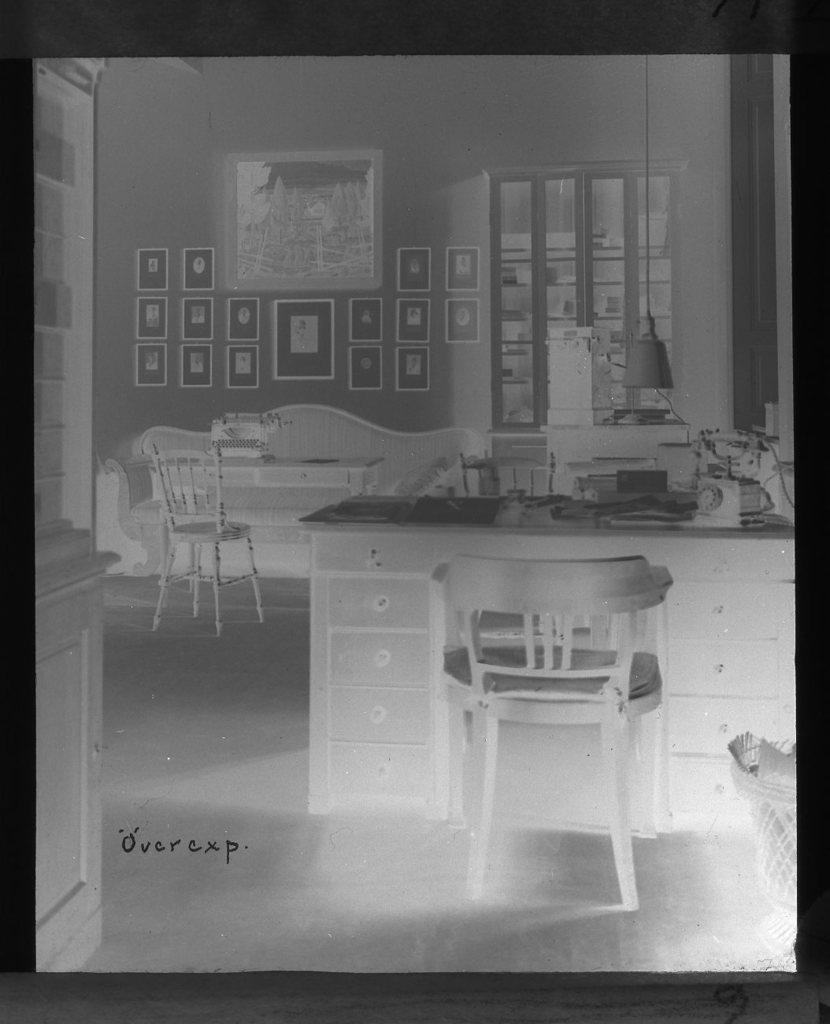Could you give a brief overview of what you see in this image? It is a black and white edited image there is a table, chair, sofa set and there are some frames attached to the wall in the background and on the right side there are some windows. 